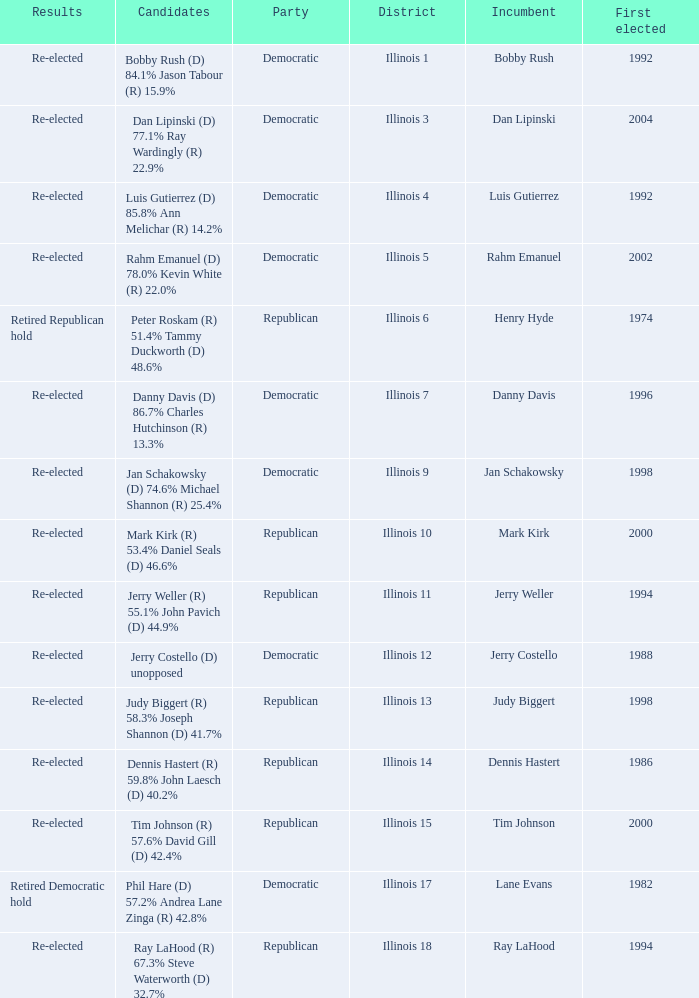Who were the candidates when the first elected was a republican in 1998?  Judy Biggert (R) 58.3% Joseph Shannon (D) 41.7%. Help me parse the entirety of this table. {'header': ['Results', 'Candidates', 'Party', 'District', 'Incumbent', 'First elected'], 'rows': [['Re-elected', 'Bobby Rush (D) 84.1% Jason Tabour (R) 15.9%', 'Democratic', 'Illinois 1', 'Bobby Rush', '1992'], ['Re-elected', 'Dan Lipinski (D) 77.1% Ray Wardingly (R) 22.9%', 'Democratic', 'Illinois 3', 'Dan Lipinski', '2004'], ['Re-elected', 'Luis Gutierrez (D) 85.8% Ann Melichar (R) 14.2%', 'Democratic', 'Illinois 4', 'Luis Gutierrez', '1992'], ['Re-elected', 'Rahm Emanuel (D) 78.0% Kevin White (R) 22.0%', 'Democratic', 'Illinois 5', 'Rahm Emanuel', '2002'], ['Retired Republican hold', 'Peter Roskam (R) 51.4% Tammy Duckworth (D) 48.6%', 'Republican', 'Illinois 6', 'Henry Hyde', '1974'], ['Re-elected', 'Danny Davis (D) 86.7% Charles Hutchinson (R) 13.3%', 'Democratic', 'Illinois 7', 'Danny Davis', '1996'], ['Re-elected', 'Jan Schakowsky (D) 74.6% Michael Shannon (R) 25.4%', 'Democratic', 'Illinois 9', 'Jan Schakowsky', '1998'], ['Re-elected', 'Mark Kirk (R) 53.4% Daniel Seals (D) 46.6%', 'Republican', 'Illinois 10', 'Mark Kirk', '2000'], ['Re-elected', 'Jerry Weller (R) 55.1% John Pavich (D) 44.9%', 'Republican', 'Illinois 11', 'Jerry Weller', '1994'], ['Re-elected', 'Jerry Costello (D) unopposed', 'Democratic', 'Illinois 12', 'Jerry Costello', '1988'], ['Re-elected', 'Judy Biggert (R) 58.3% Joseph Shannon (D) 41.7%', 'Republican', 'Illinois 13', 'Judy Biggert', '1998'], ['Re-elected', 'Dennis Hastert (R) 59.8% John Laesch (D) 40.2%', 'Republican', 'Illinois 14', 'Dennis Hastert', '1986'], ['Re-elected', 'Tim Johnson (R) 57.6% David Gill (D) 42.4%', 'Republican', 'Illinois 15', 'Tim Johnson', '2000'], ['Retired Democratic hold', 'Phil Hare (D) 57.2% Andrea Lane Zinga (R) 42.8%', 'Democratic', 'Illinois 17', 'Lane Evans', '1982'], ['Re-elected', 'Ray LaHood (R) 67.3% Steve Waterworth (D) 32.7%', 'Republican', 'Illinois 18', 'Ray LaHood', '1994']]} 